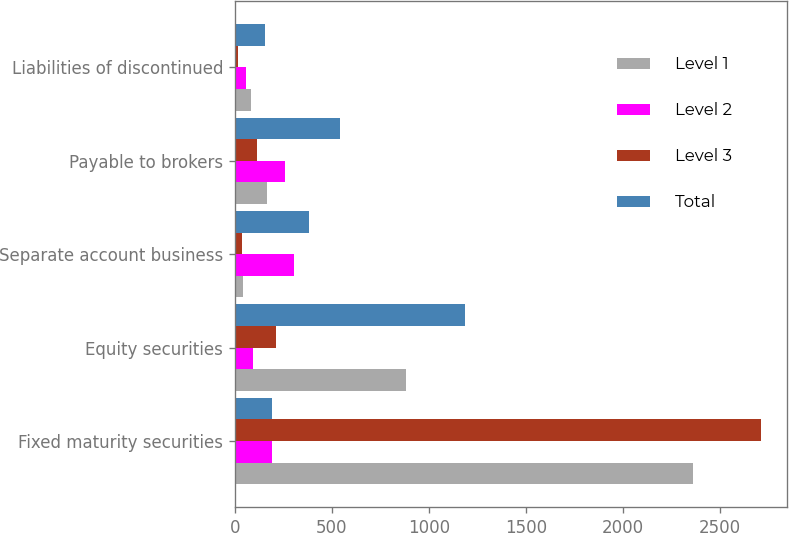Convert chart. <chart><loc_0><loc_0><loc_500><loc_500><stacked_bar_chart><ecel><fcel>Fixed maturity securities<fcel>Equity securities<fcel>Separate account business<fcel>Payable to brokers<fcel>Liabilities of discontinued<nl><fcel>Level 1<fcel>2358<fcel>881<fcel>40<fcel>168<fcel>83<nl><fcel>Level 2<fcel>189<fcel>94<fcel>306<fcel>260<fcel>59<nl><fcel>Level 3<fcel>2710<fcel>210<fcel>38<fcel>112<fcel>15<nl><fcel>Total<fcel>189<fcel>1185<fcel>384<fcel>540<fcel>157<nl></chart> 